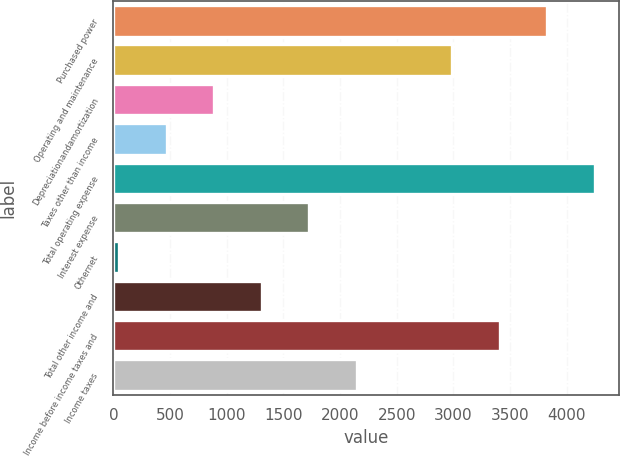<chart> <loc_0><loc_0><loc_500><loc_500><bar_chart><fcel>Purchased power<fcel>Operating and maintenance<fcel>Depreciationandamortization<fcel>Taxes other than income<fcel>Total operating expense<fcel>Interest expense<fcel>Othernet<fcel>Total other income and<fcel>Income before income taxes and<fcel>Income taxes<nl><fcel>3827.2<fcel>2987.6<fcel>888.6<fcel>468.8<fcel>4247<fcel>1728.2<fcel>49<fcel>1308.4<fcel>3407.4<fcel>2148<nl></chart> 